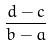<formula> <loc_0><loc_0><loc_500><loc_500>\frac { d - c } { b - a }</formula> 